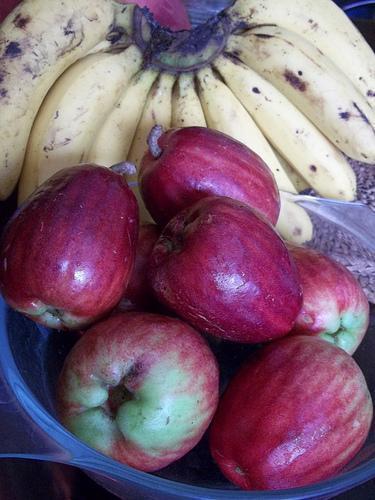How many people are in this photo?
Give a very brief answer. 0. How many bananas are there?
Give a very brief answer. 9. 